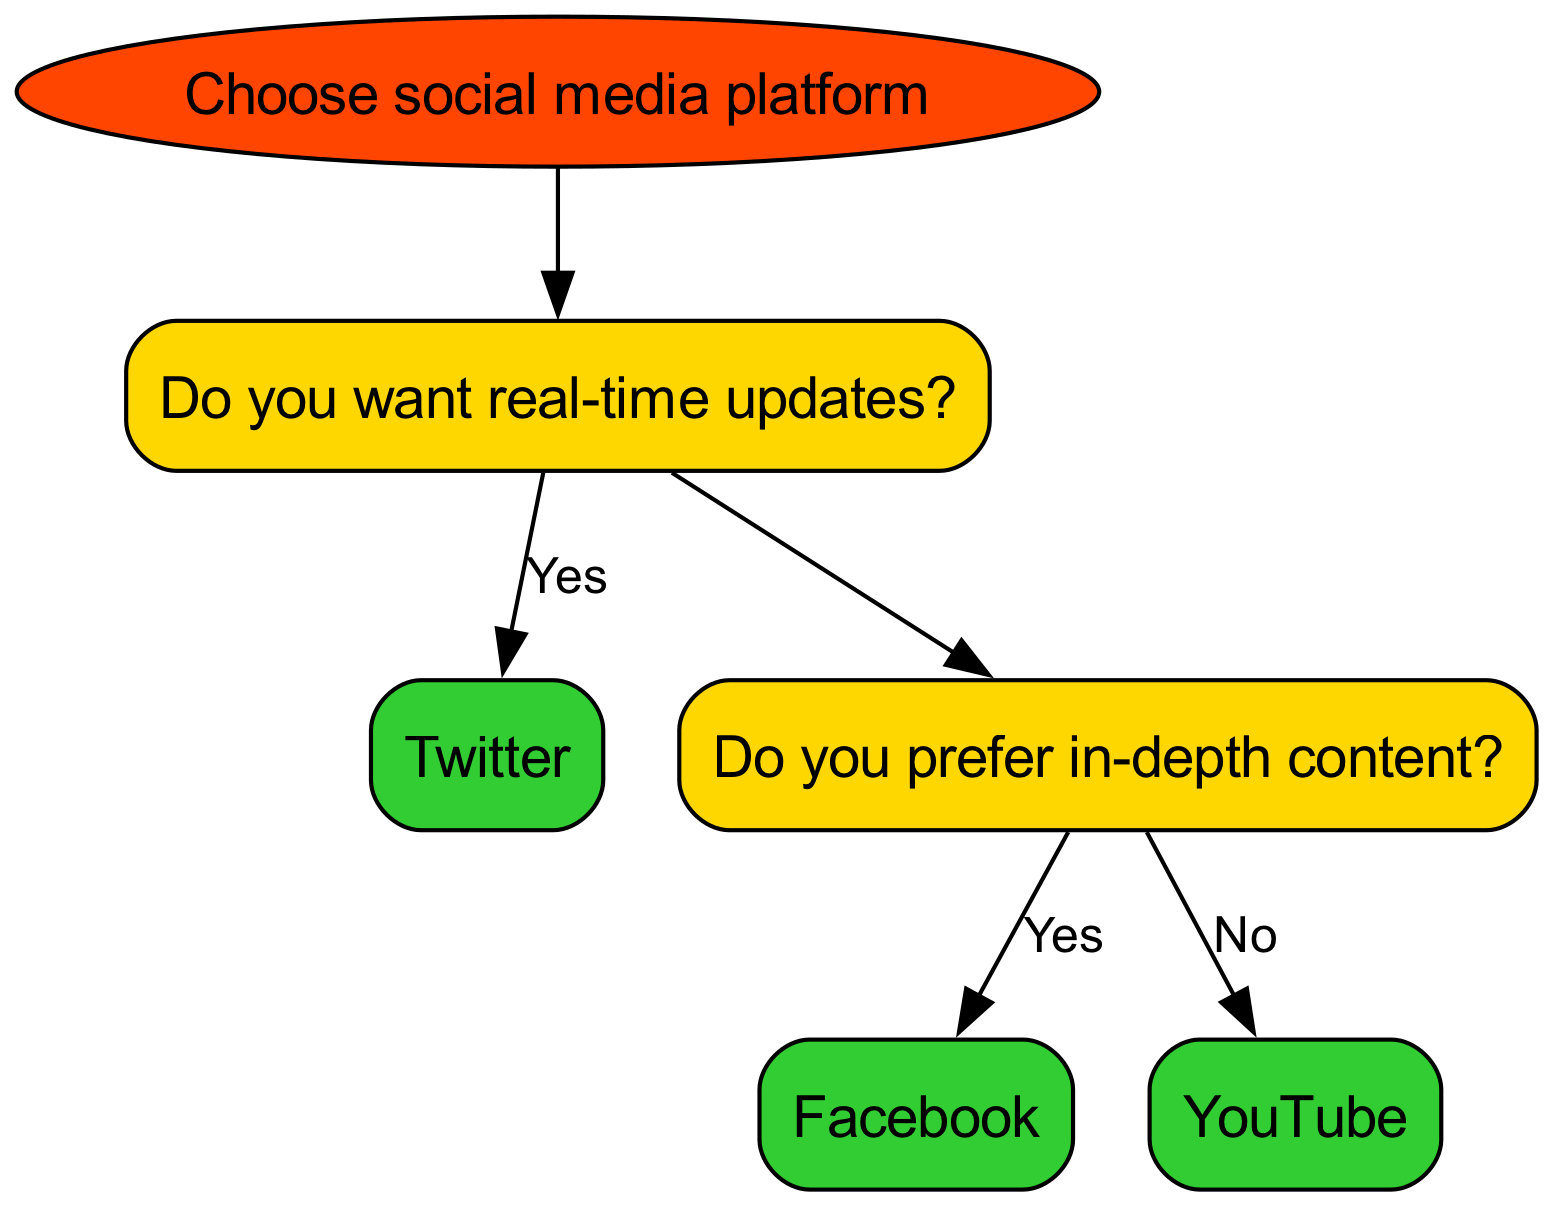What is the root of the decision tree? The root node represents the starting point of the decision-making process, which in this case is "Choose social media platform."
Answer: Choose social media platform How many leaf nodes are present in the diagram? The leaf nodes are the final outcomes without further questions, which are "Instagram," "Twitter," "Facebook," and "YouTube," totaling four.
Answer: Four What platform is suggested if you prefer visual content? According to the edge that leads from the question "Do you prefer visual content?" to the corresponding answer node, the suggested platform is "Instagram."
Answer: Instagram What is the next platform if you do not want real-time updates and prefer in-depth content? Following the path for those who do not want real-time updates and instead prefer in-depth content directly leads to the answer node "Facebook."
Answer: Facebook If someone prefers neither visual content nor in-depth content, which platform will they end up being directed to? If the user chooses "No" for visual content and then "No" for in-depth content, they follow the path to the final leaf node "YouTube."
Answer: YouTube What is the edge label leading from "Do you prefer in-depth content?" to its "Yes" node? The "Yes" response from the "Do you prefer in-depth content?" question directly connects to the leaf node "Facebook," which signifies that it is the platform for users prioritizing this type of content.
Answer: Facebook Which platform do you get if you want real-time updates? The path from the "Do you want real-time updates?" question shows that saying "Yes" leads directly to the node labeled "Twitter."
Answer: Twitter What are the edges from the node "Do you want real-time updates?"? From the question node "Do you want real-time updates?", two edges diverage: one to "Yes" leading to "Twitter" and another to "No" leading to the question "Do you prefer in-depth content?".
Answer: Yes and No 